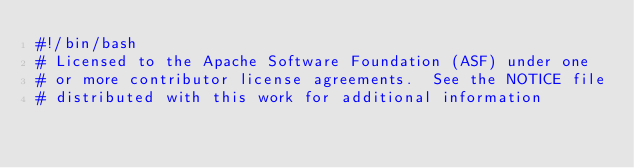<code> <loc_0><loc_0><loc_500><loc_500><_Bash_>#!/bin/bash
# Licensed to the Apache Software Foundation (ASF) under one
# or more contributor license agreements.  See the NOTICE file
# distributed with this work for additional information</code> 